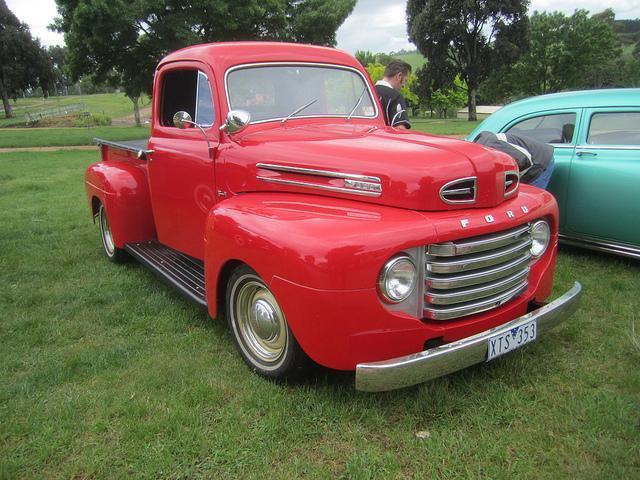How many cars are in the photo?
Give a very brief answer. 2. 